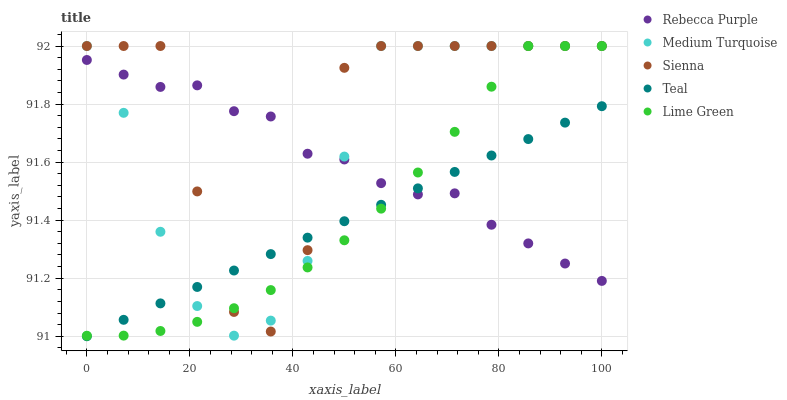Does Teal have the minimum area under the curve?
Answer yes or no. Yes. Does Sienna have the maximum area under the curve?
Answer yes or no. Yes. Does Lime Green have the minimum area under the curve?
Answer yes or no. No. Does Lime Green have the maximum area under the curve?
Answer yes or no. No. Is Teal the smoothest?
Answer yes or no. Yes. Is Sienna the roughest?
Answer yes or no. Yes. Is Lime Green the smoothest?
Answer yes or no. No. Is Lime Green the roughest?
Answer yes or no. No. Does Teal have the lowest value?
Answer yes or no. Yes. Does Lime Green have the lowest value?
Answer yes or no. No. Does Medium Turquoise have the highest value?
Answer yes or no. Yes. Does Teal have the highest value?
Answer yes or no. No. Does Medium Turquoise intersect Teal?
Answer yes or no. Yes. Is Medium Turquoise less than Teal?
Answer yes or no. No. Is Medium Turquoise greater than Teal?
Answer yes or no. No. 